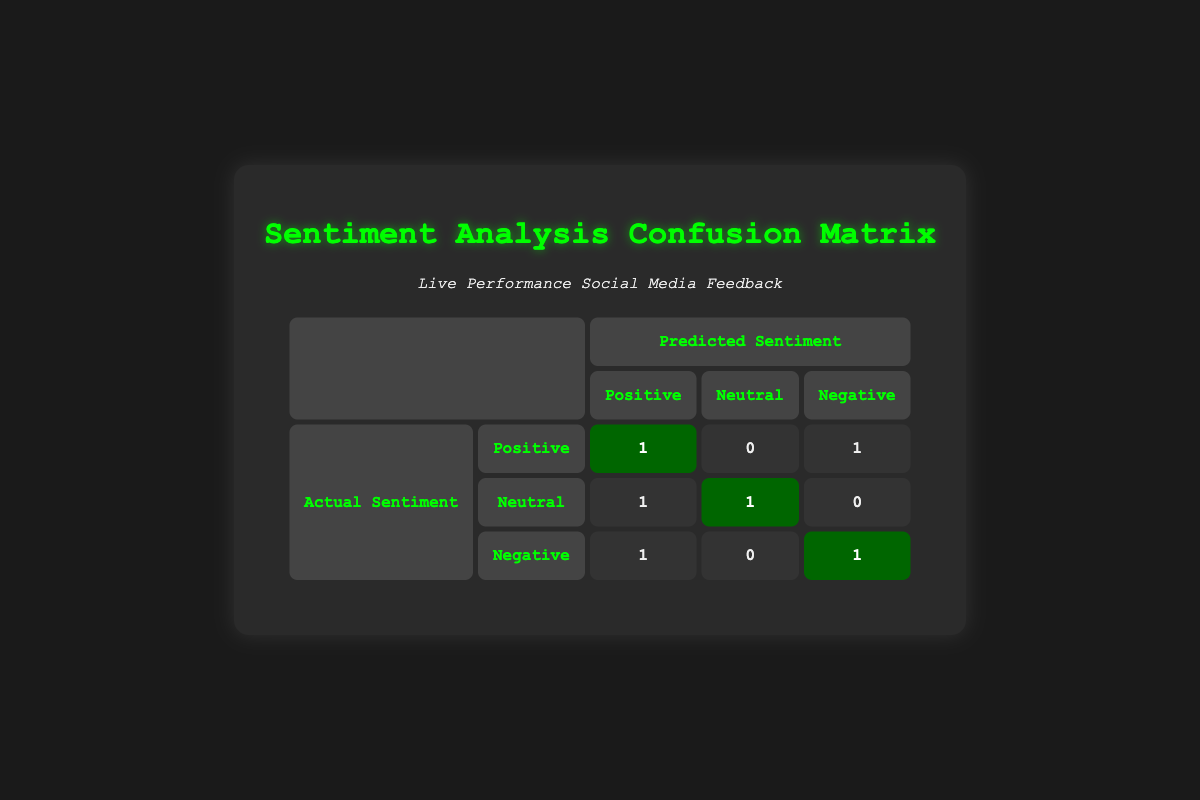What is the total number of actual positive sentiments? There is one instance of actual positive sentiment in the table, which can be seen in the first row where the actual sentiment is "Positive" and the predicted sentiment is also "Positive."
Answer: 1 How many times was the predicted sentiment negative when the actual sentiment was positive? Looking at the table, the predicted sentiment is negative in one instance when the actual sentiment is positive, specifically in the fourth row.
Answer: 1 What is the total count of neutral sentiments predicted? The predicted sentiment is classified as neutral in two instances in the table, one of which can be seen in the third row where the actual sentiment is neutral, and the other in the sixth row where the actual sentiment is neutral too.
Answer: 2 Did the model predict negative sentiment more frequently than it predicted positive sentiment? The table shows that the predicted negative sentiment occurs three times (twice for actual sentiment negative and once for actual positive), while predicted positive sentiment occurs only two times (once actual is positive and once actual is neutral). Thus, it is true that negative predictions are more frequent.
Answer: Yes What is the proportion of true positives out of the total predictions made? The total predictions made in the table are six. Out of these, there is only one true positive (where both actual and predicted sentiments are positive). The proportion is calculated as 1 true positive out of 6 total predictions, which equals 1/6 or approximately 0.17.
Answer: 0.17 How many instances were classified as actual negative sentiments? There are two instances classified as actual negative sentiments in the table, visible in the fifth row and the last row where "Negative" appears in the actual sentiment column.
Answer: 2 What is the accuracy of the predictions based on the data provided? To find accuracy, we take the number of correct predictions and divide it by the total number of predictions. The correct predictions are those in rows where actual and predicted sentiments match: one true positive, one true neutral, and two true negatives. That is 4 out of 6, so accuracy is 4/6 = 0.67.
Answer: 0.67 What is the count of neutral sentiments predicted when the actual sentiment was neutral? There is one instance where the actual sentiment is neutral and the predicted sentiment is also neutral, which can be seen in the third row of the table.
Answer: 1 How many total instances have neutral sentiments as either actual or predicted? Counting both actual and predicted neutral sentiments, actual neutral appears in two rows (third and sixth) and predicted neutral appears in three rows (third, second, and sixth). Thus, the total distinct instances where either sentiment is neutral is two.
Answer: 2 